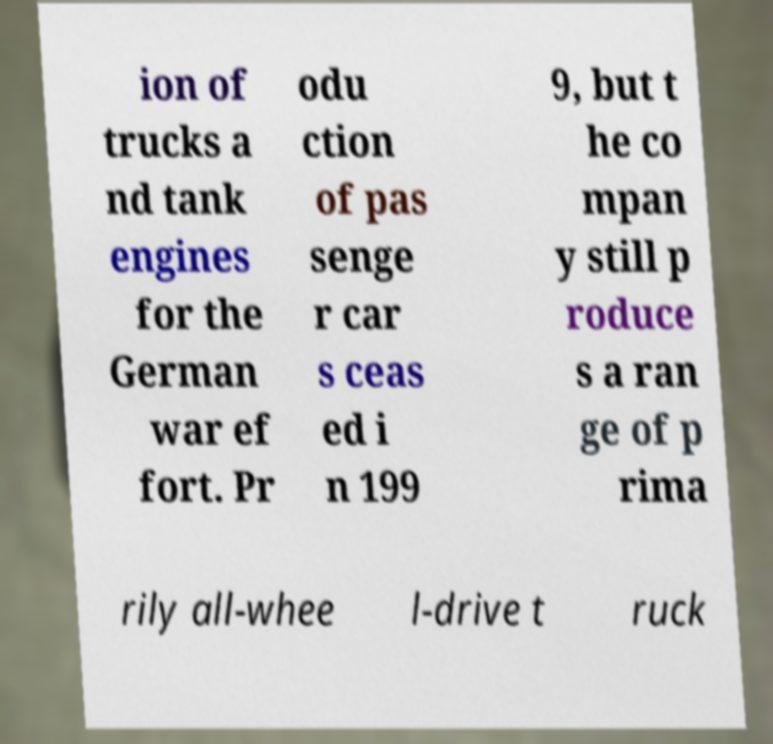Please identify and transcribe the text found in this image. ion of trucks a nd tank engines for the German war ef fort. Pr odu ction of pas senge r car s ceas ed i n 199 9, but t he co mpan y still p roduce s a ran ge of p rima rily all-whee l-drive t ruck 